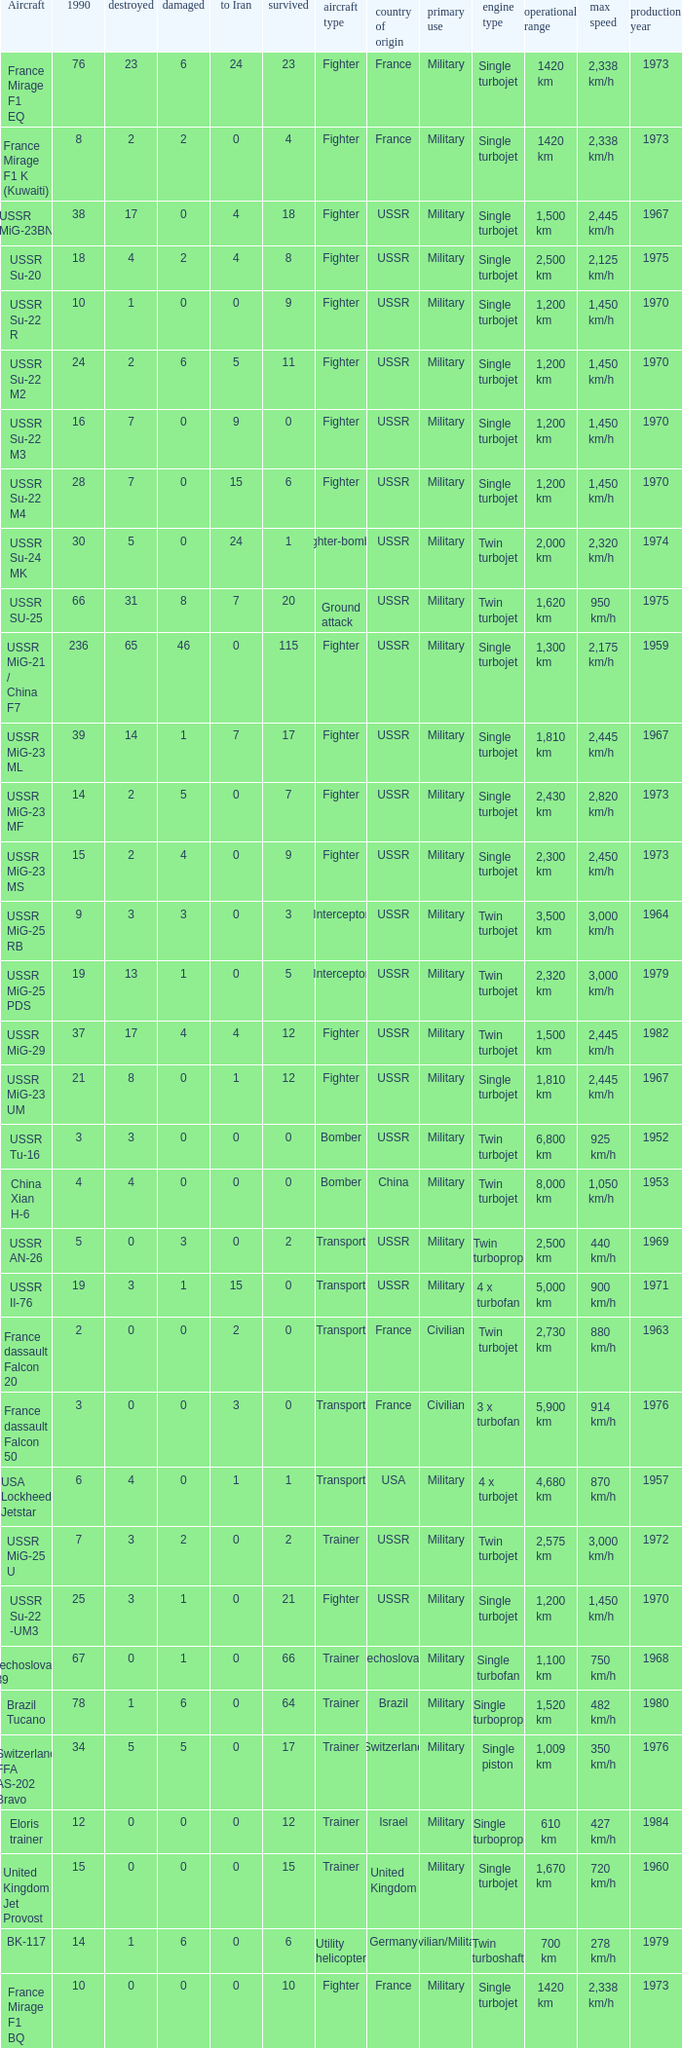If 4 went to iran and the amount that survived was less than 12.0 how many were there in 1990? 1.0. 